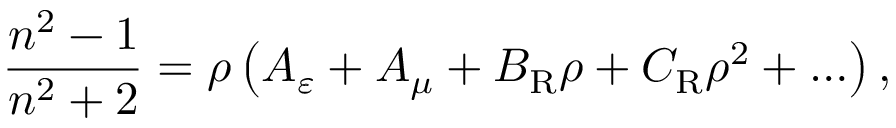Convert formula to latex. <formula><loc_0><loc_0><loc_500><loc_500>\frac { n ^ { 2 } - 1 } { n ^ { 2 } + 2 } = \rho \left ( A _ { \varepsilon } + A _ { \mu } + B _ { R } \rho + C _ { R } \rho ^ { 2 } + \dots \right ) ,</formula> 